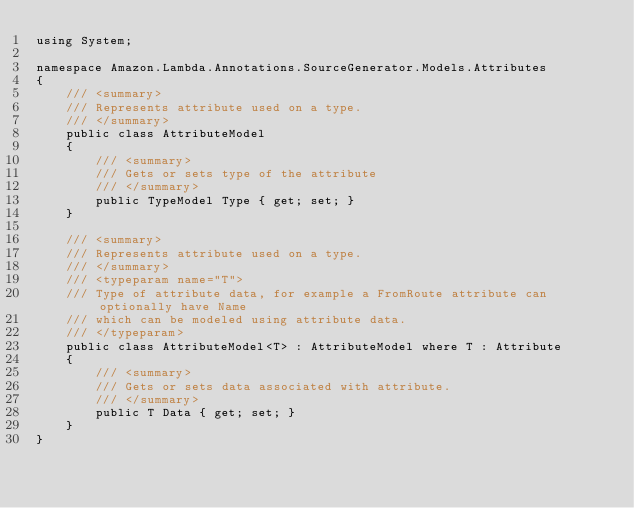Convert code to text. <code><loc_0><loc_0><loc_500><loc_500><_C#_>using System;

namespace Amazon.Lambda.Annotations.SourceGenerator.Models.Attributes
{
    /// <summary>
    /// Represents attribute used on a type.
    /// </summary>
    public class AttributeModel
    {
        /// <summary>
        /// Gets or sets type of the attribute
        /// </summary>
        public TypeModel Type { get; set; }
    }

    /// <summary>
    /// Represents attribute used on a type.
    /// </summary>
    /// <typeparam name="T">
    /// Type of attribute data, for example a FromRoute attribute can optionally have Name
    /// which can be modeled using attribute data.
    /// </typeparam>
    public class AttributeModel<T> : AttributeModel where T : Attribute
    {
        /// <summary>
        /// Gets or sets data associated with attribute.
        /// </summary>
        public T Data { get; set; }
    }
}</code> 